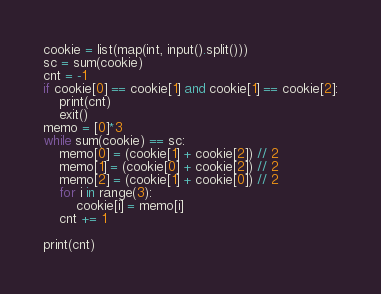Convert code to text. <code><loc_0><loc_0><loc_500><loc_500><_Python_>cookie = list(map(int, input().split()))
sc = sum(cookie)
cnt = -1
if cookie[0] == cookie[1] and cookie[1] == cookie[2]:
    print(cnt)
    exit()
memo = [0]*3
while sum(cookie) == sc:
    memo[0] = (cookie[1] + cookie[2]) // 2
    memo[1] = (cookie[0] + cookie[2]) // 2
    memo[2] = (cookie[1] + cookie[0]) // 2
    for i in range(3):
        cookie[i] = memo[i]
    cnt += 1

print(cnt)</code> 